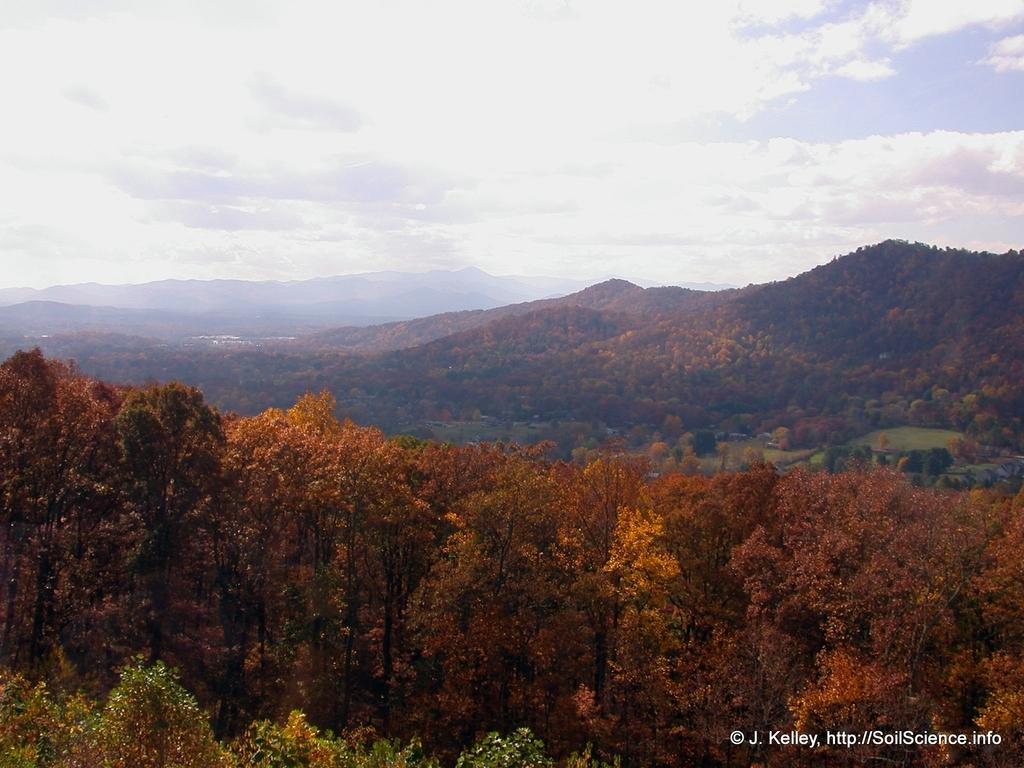What type of vegetation can be seen in the image? There are trees in the image. What geographical features are present in the image? There are hills in the image. What can be seen in the background of the image? The sky is visible in the background of the image. Is there any text or marking in the image? Yes, there is a watermark in the bottom right corner of the image. How many tomatoes are hanging from the trees in the image? There are no tomatoes present in the image; it features trees and hills. What type of lace can be seen on the hills in the image? There is no lace present in the image; it features trees and hills with a visible sky in the background. 